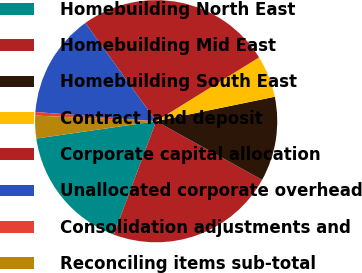Convert chart to OTSL. <chart><loc_0><loc_0><loc_500><loc_500><pie_chart><fcel>Homebuilding North East<fcel>Homebuilding Mid East<fcel>Homebuilding South East<fcel>Contract land deposit<fcel>Corporate capital allocation<fcel>Unallocated corporate overhead<fcel>Consolidation adjustments and<fcel>Reconciling items sub-total<nl><fcel>17.01%<fcel>22.65%<fcel>11.28%<fcel>5.6%<fcel>26.1%<fcel>13.85%<fcel>0.47%<fcel>3.03%<nl></chart> 